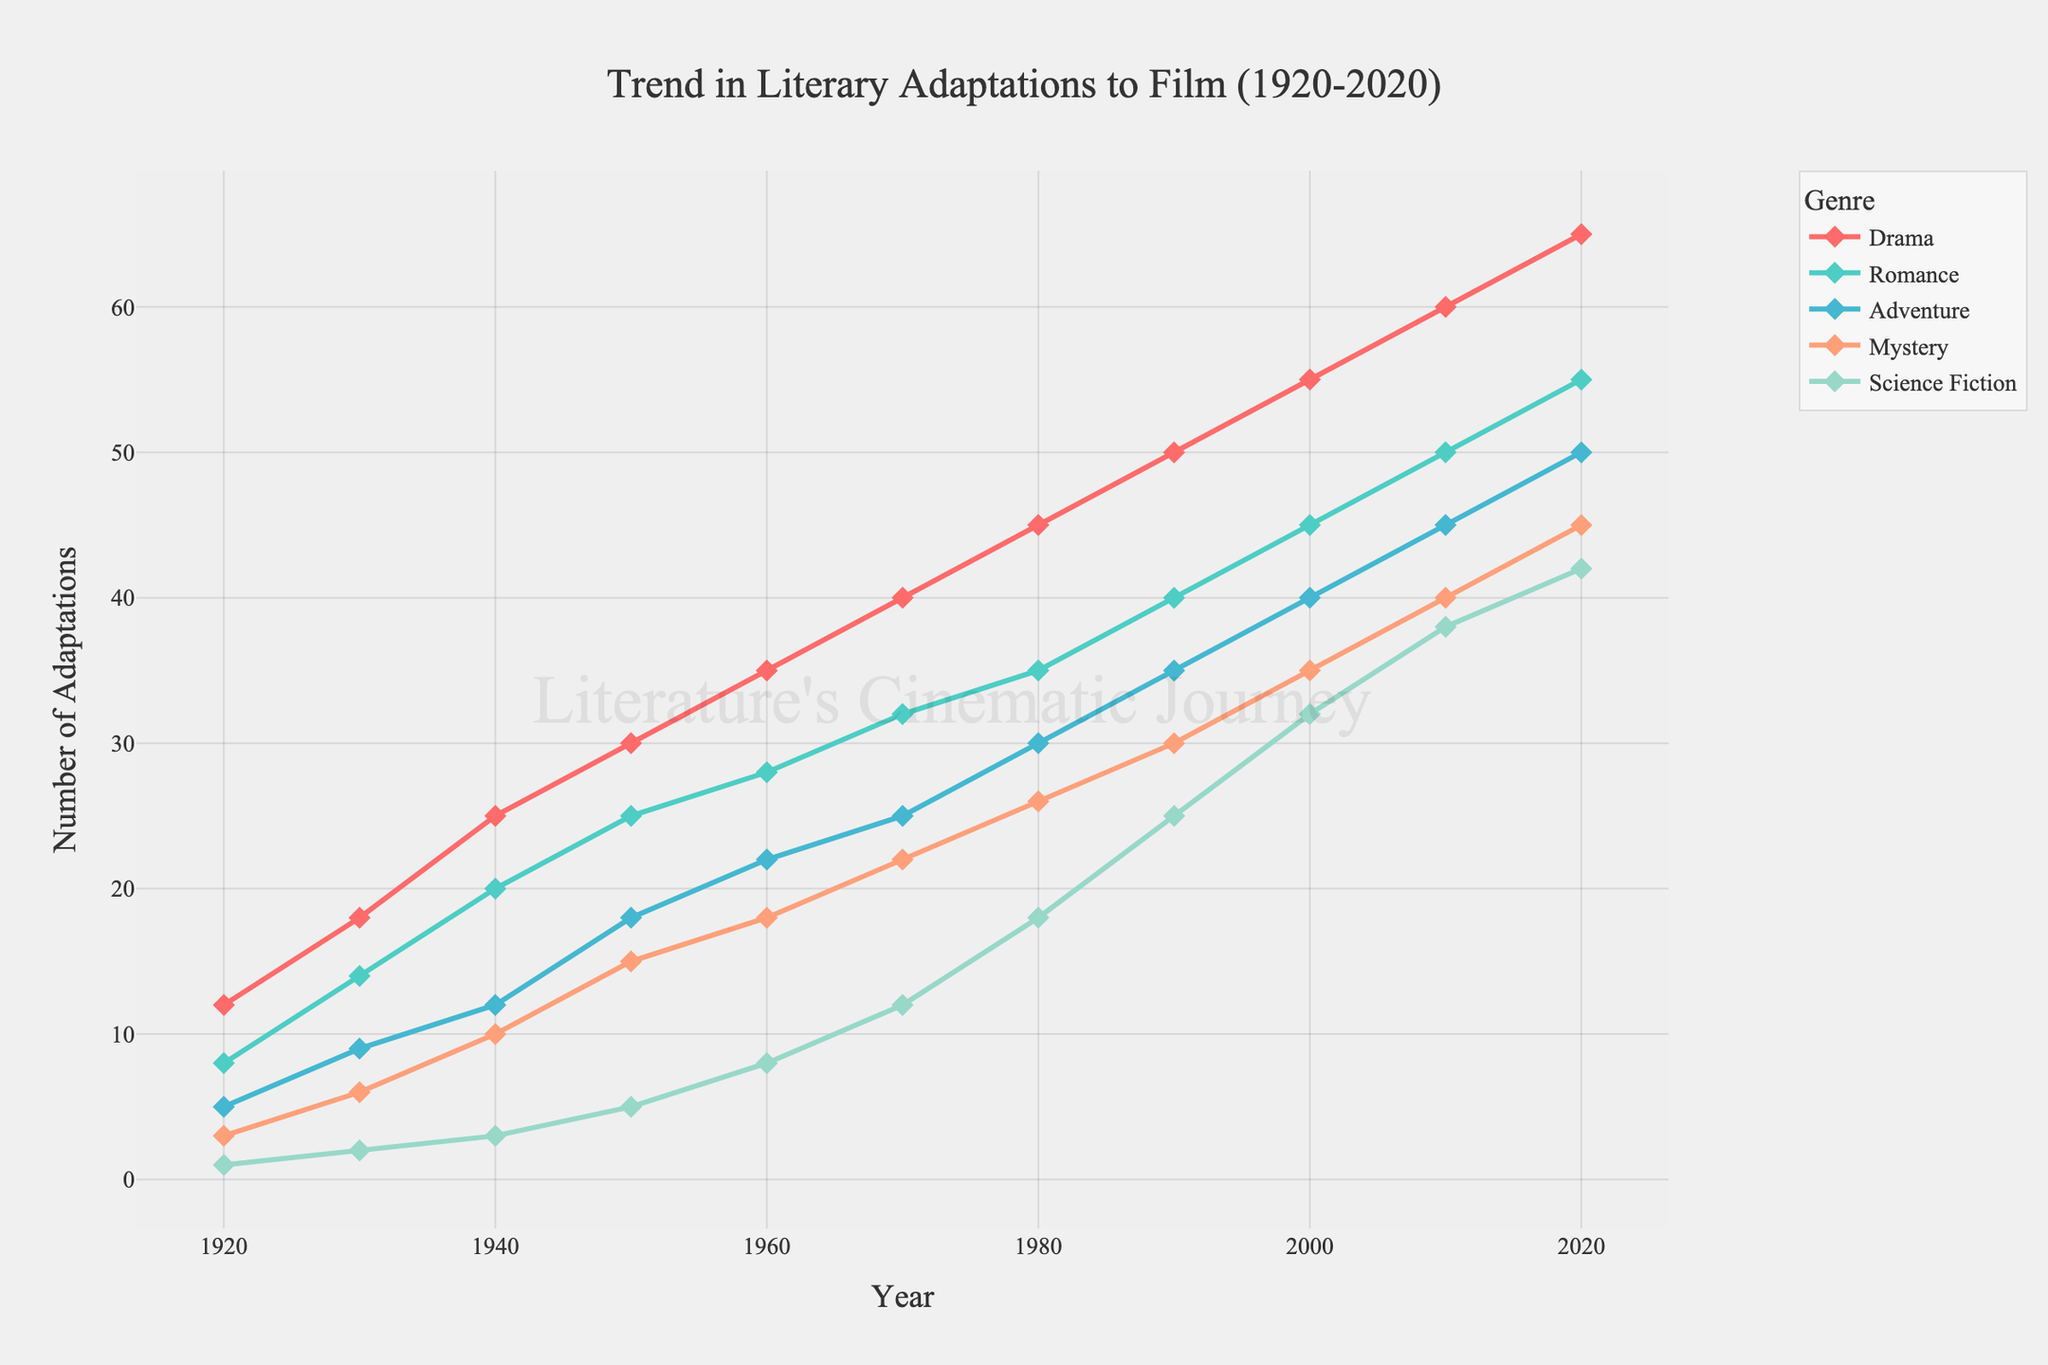How many Drama literary adaptations were made in the year 1950? Look for the year 1950 along the x-axis and find the corresponding value for Drama on the y-axis. It shows 30.
Answer: 30 Which genre saw the highest number of adaptations in 2010? Identify the year 2010 on the x-axis and compare the heights of the lines for each genre. The Drama line is the highest.
Answer: Drama By how much did the number of Science Fiction adaptations increase from 1940 to 2020? Find the Science Fiction values for 1940 and 2020 on the y-axis (3 and 42, respectively). Compute the difference: 42 - 3 = 39.
Answer: 39 On average, how many adaptations of Romance were made every decade from 1920 to 2020? Sum the Romance values for each decade (8 + 14 + 20 + 25 + 28 + 32 + 35 + 40 + 45 + 50 + 55) equals 352. Divide by the number of decades (11). 352/11 = 32.
Answer: 32 Which two genres show the greatest difference in number of adaptations in 1970? What is the difference? For 1970, find the y-values: Drama (40), Romance (32), Adventure (25), Mystery (22), Science Fiction (12). Drama and Science Fiction show the greatest difference: 40 - 12 = 28.
Answer: 28 Has the number of Adventure adaptations ever surpassed that of Romance from 1920 to 2020? Compare the Adventure and Romance values for each decade. The Adventure values are always lower than Romance values.
Answer: No In the year 2000, what is the combined total of literary adaptations for all genres? Sum the y-values for all genres in 2000: 55 (Drama) + 45 (Romance) + 40 (Adventure) + 35 (Mystery) + 32 (Science Fiction) = 207.
Answer: 207 What is the trend in the number of Mystery adaptations from 1950 to 2000? Examine and describe the y-values for Mystery from 1950 (15) to 2000 (35). The values show a consistent increase over time.
Answer: Increasing Which genre shows the smallest growth from 1920 to 2020? Compare the growth for each genre: Drama (65-12=53), Romance (55-8=47), Adventure (50-5=45), Mystery (45-3=42), Science Fiction (42-1=41). Science Fiction has the smallest growth.
Answer: Science Fiction By how much has the number of Drama adaptations grown between 1930 and 1960? Find the Drama values for 1930 (18) and 1960 (35). Subtract to find the growth: 35-18=17.
Answer: 17 